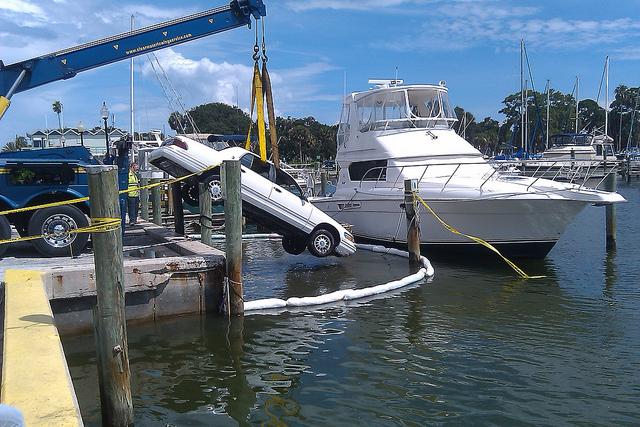What fell in the water?
Give a very brief answer. Car. What is lifting the car?
Short answer required. Crane. Where is reflection?
Write a very short answer. Water. Does this boat use sails for power?
Be succinct. No. 